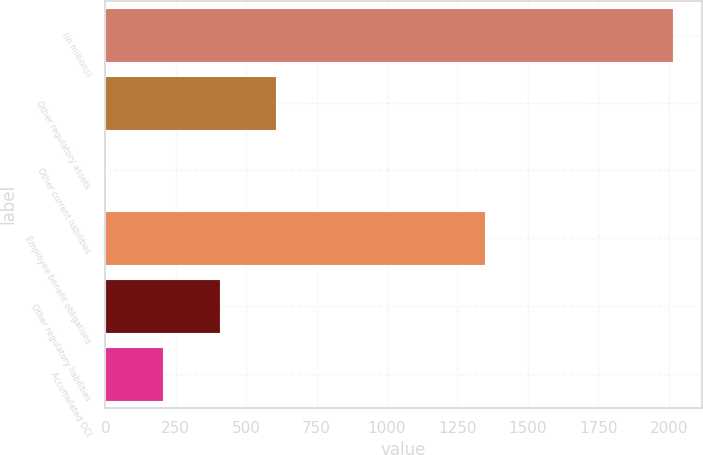Convert chart. <chart><loc_0><loc_0><loc_500><loc_500><bar_chart><fcel>(in millions)<fcel>Other regulatory assets<fcel>Other current liabilities<fcel>Employee benefit obligations<fcel>Other regulatory liabilities<fcel>Accumulated OCI<nl><fcel>2016<fcel>607.6<fcel>4<fcel>1349<fcel>406.4<fcel>205.2<nl></chart> 